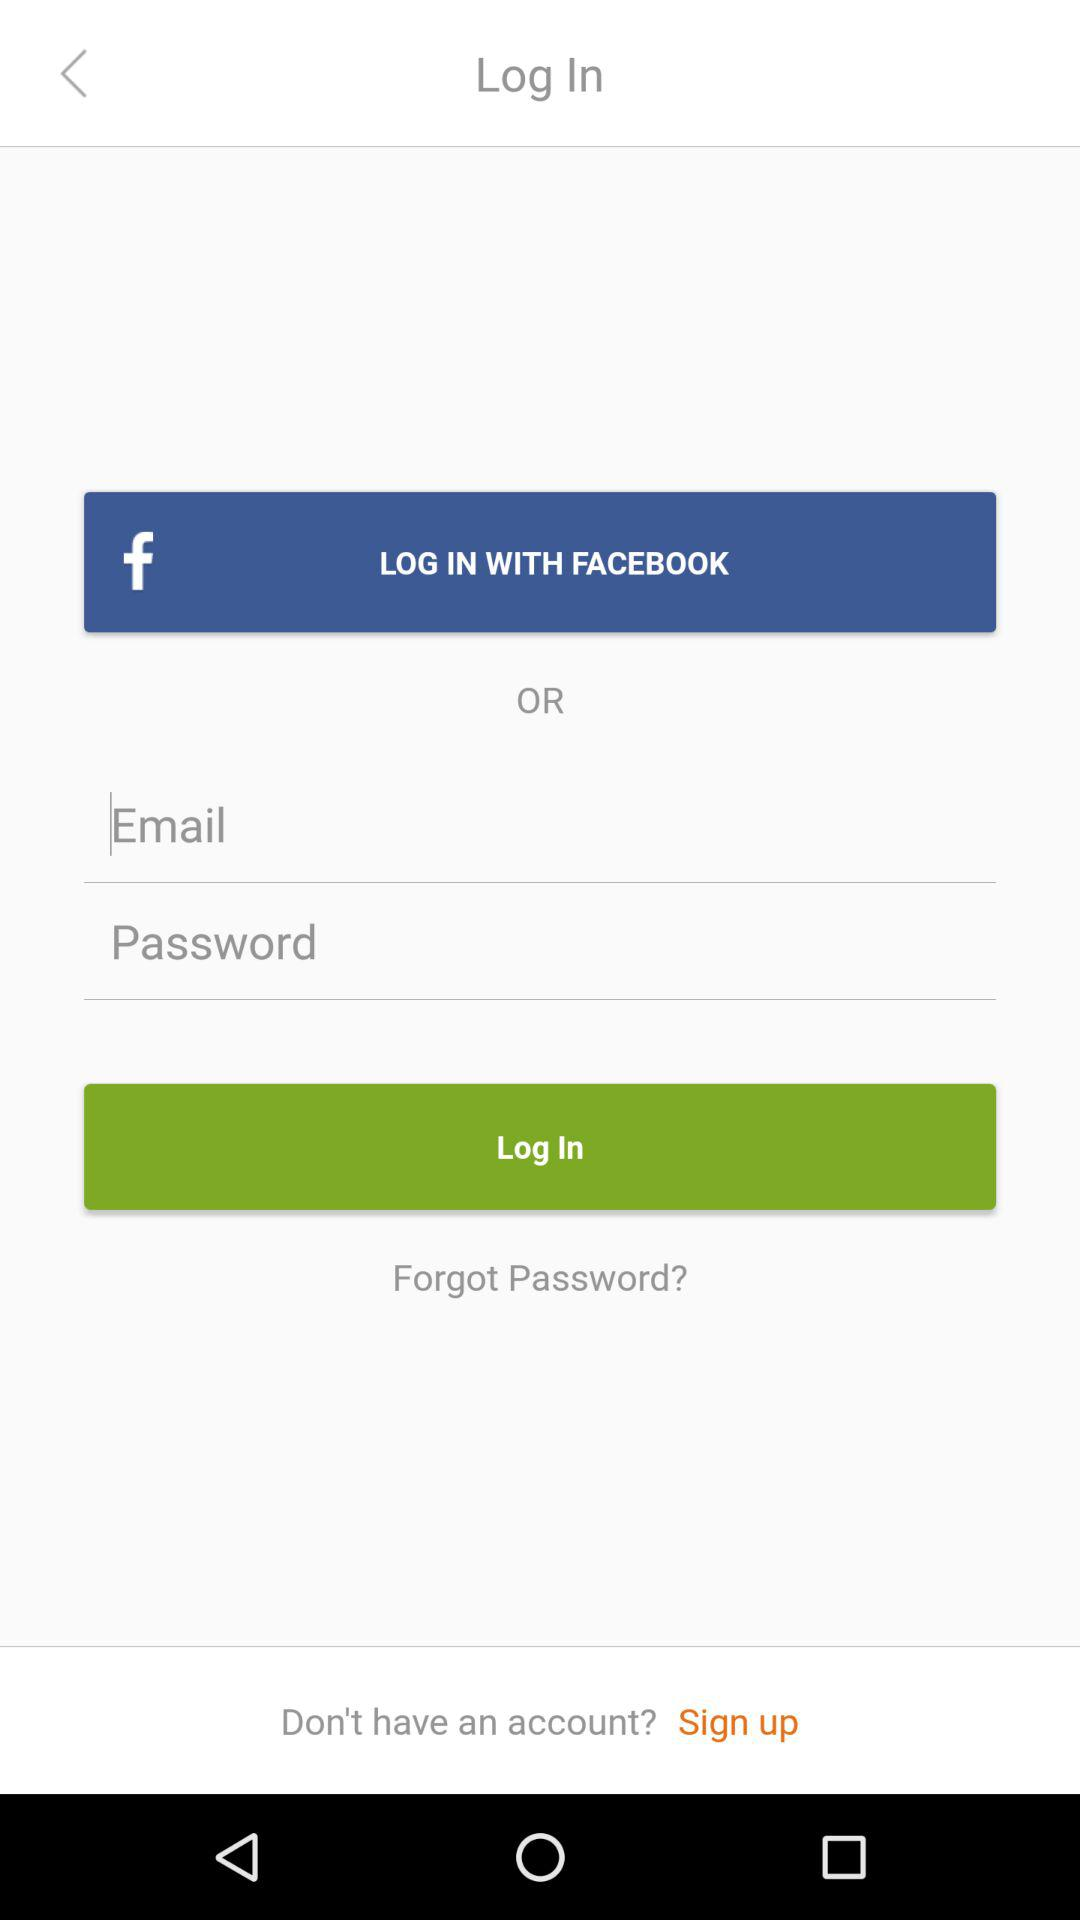How many input fields are there for logging in?
Answer the question using a single word or phrase. 2 